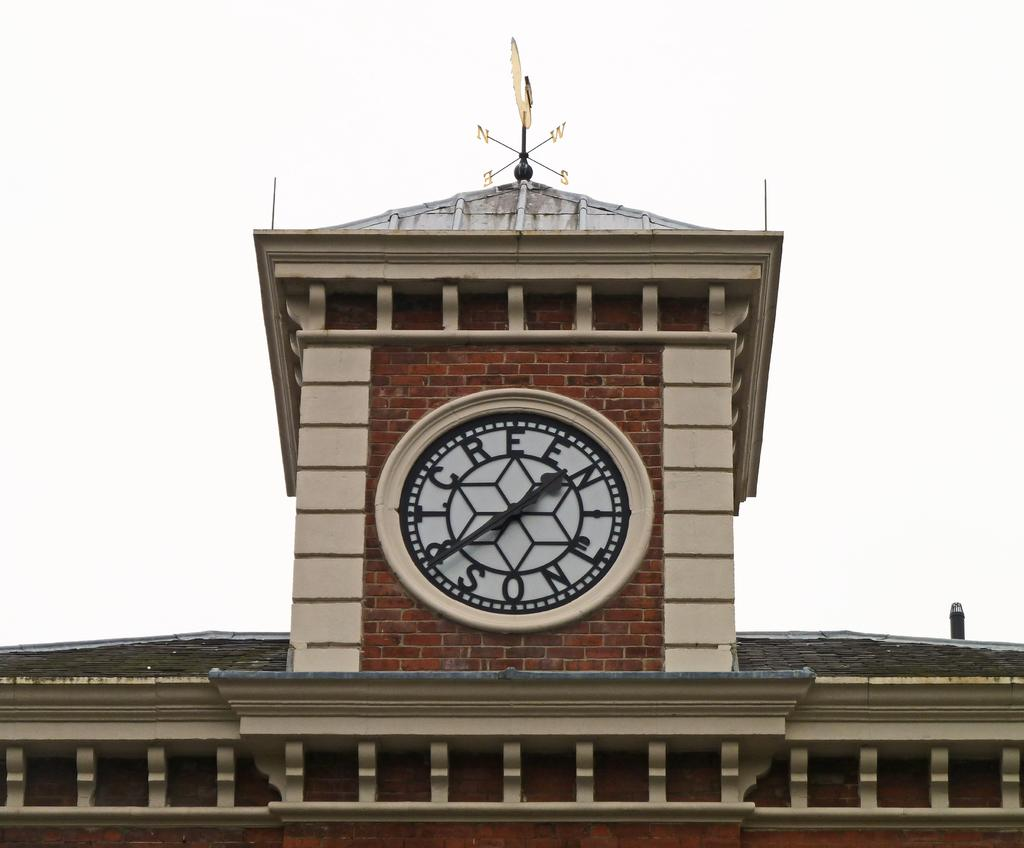Provide a one-sentence caption for the provided image. A Large clock sits on a the top of a building with letters where the numbers would normally be. 